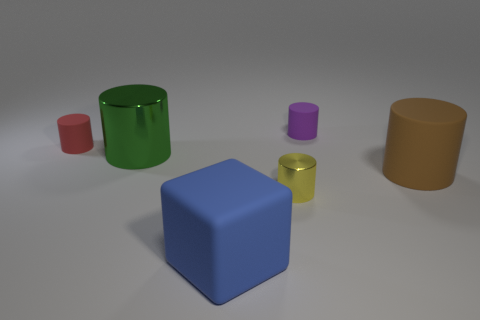Subtract all green cylinders. How many cylinders are left? 4 Subtract all big rubber cylinders. How many cylinders are left? 4 Subtract all blue cylinders. Subtract all cyan balls. How many cylinders are left? 5 Add 2 large metal cylinders. How many objects exist? 8 Subtract all cylinders. How many objects are left? 1 Subtract 0 yellow balls. How many objects are left? 6 Subtract all red metal balls. Subtract all tiny purple rubber cylinders. How many objects are left? 5 Add 4 metallic cylinders. How many metallic cylinders are left? 6 Add 1 blue matte cubes. How many blue matte cubes exist? 2 